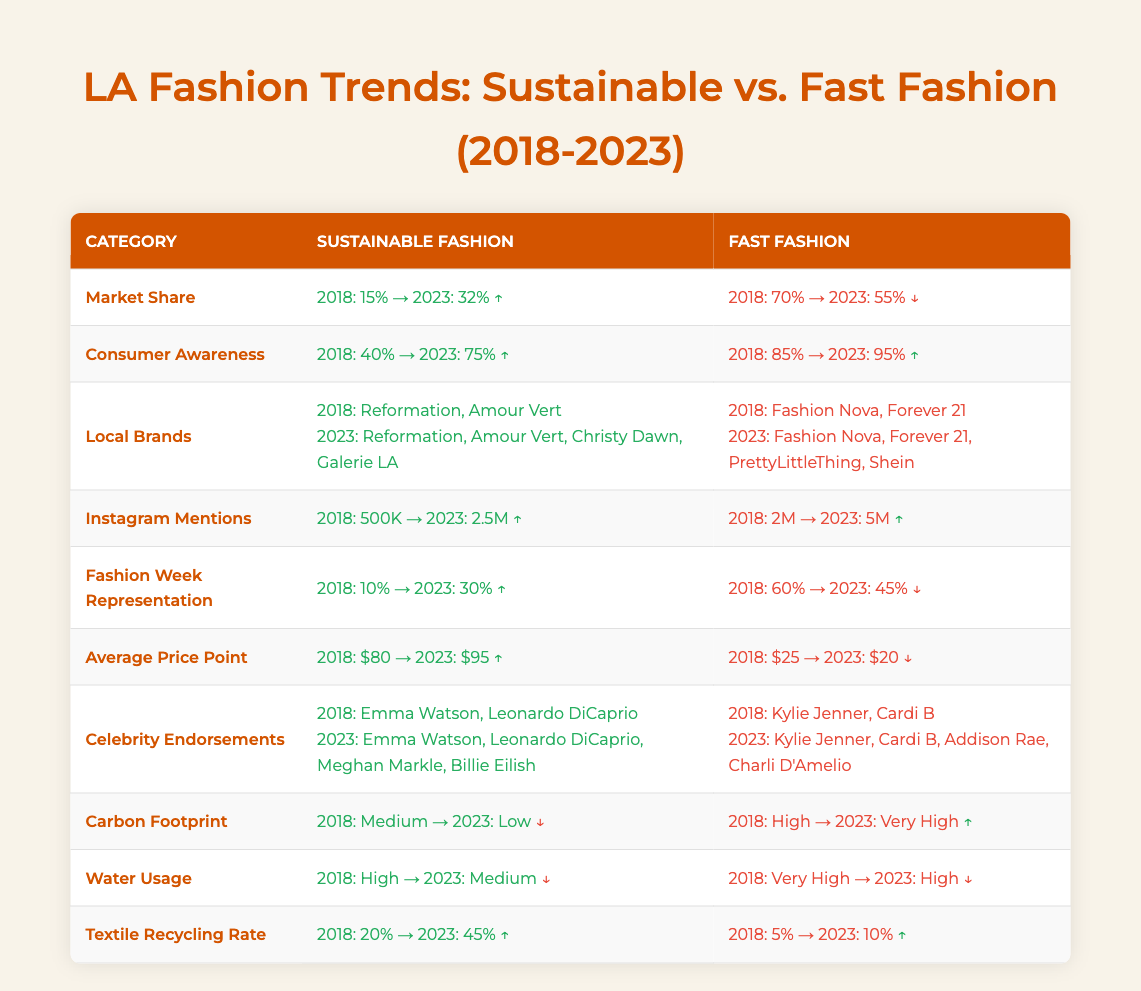What is the market share of sustainable fashion in 2023? The table shows that the market share for sustainable fashion in 2023 is 32%.
Answer: 32% How many local brands were associated with sustainable fashion in 2018? In 2018, the local brands associated with sustainable fashion were Reformation and Amour Vert, making a total of 2 brands.
Answer: 2 What was the percentage increase in Instagram mentions for sustainable fashion from 2018 to 2023? The Instagram mentions for sustainable fashion in 2018 were 500K, and in 2023, they rose to 2.5M. This is a change of 2.5M - 500K = 2M which is a 400% increase from the original 500K.
Answer: 400% Did fast fashion have a higher average price point than sustainable fashion in 2023? In 2023, sustainable fashion had an average price point of $95, while fast fashion had $20, making sustainable fashion much higher.
Answer: No What is the difference in the textile recycling rate between sustainable fashion and fast fashion in 2023? In 2023, the textile recycling rate for sustainable fashion is 45% and for fast fashion, it is 10%. The difference is 45% - 10% = 35%.
Answer: 35% What was the carbon footprint level of sustainable fashion in 2018? According to the table, sustainable fashion had a medium carbon footprint in 2018.
Answer: Medium How many celebrities endorsed fast fashion in 2023 compared to 2018? In 2018, fast fashion had 2 celebrity endorsements (Kylie Jenner and Cardi B), while in 2023, it increased to 4 endorsements (adding Addison Rae and Charli D'Amelio).
Answer: 2 What is the consumer awareness percentage for fast fashion in 2023? The table indicates that consumer awareness for fast fashion in 2023 is 95%.
Answer: 95% Based on the table, did the representation of sustainable fashion in Fashion Week increase or decrease from 2018 to 2023? In 2018, sustainable fashion represented 10% at Fashion Week, and by 2023, it rose to 30%. Therefore, it increased.
Answer: Increased 